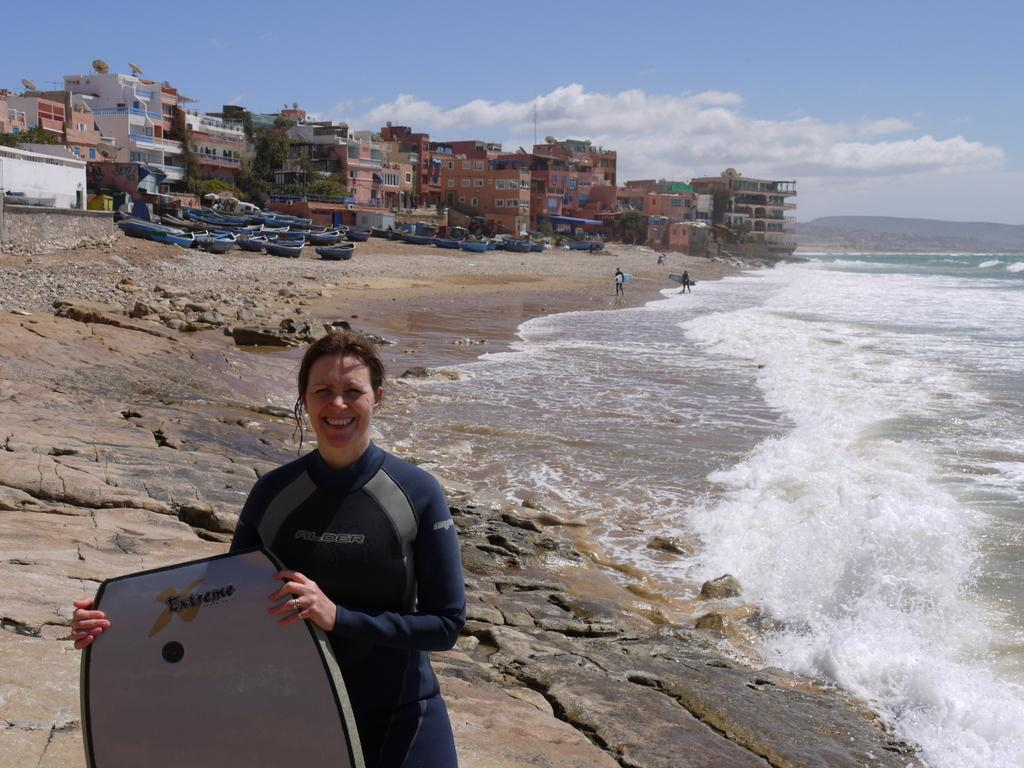Who is present in the image? There is a woman in the image. What is the woman doing? The woman is smiling and carrying a surfboard. What can be seen in the background of the image? There are boats, buildings with windows, trees, and water visible in the background. How many persons are in the background of the image? There are two persons in the background of the image. What is visible in the sky in the image? The sky is visible in the background of the image, and there are clouds present. What type of wool is being used to make the surfboard in the image? There is no wool present in the image, and the surfboard is not made of wool. 